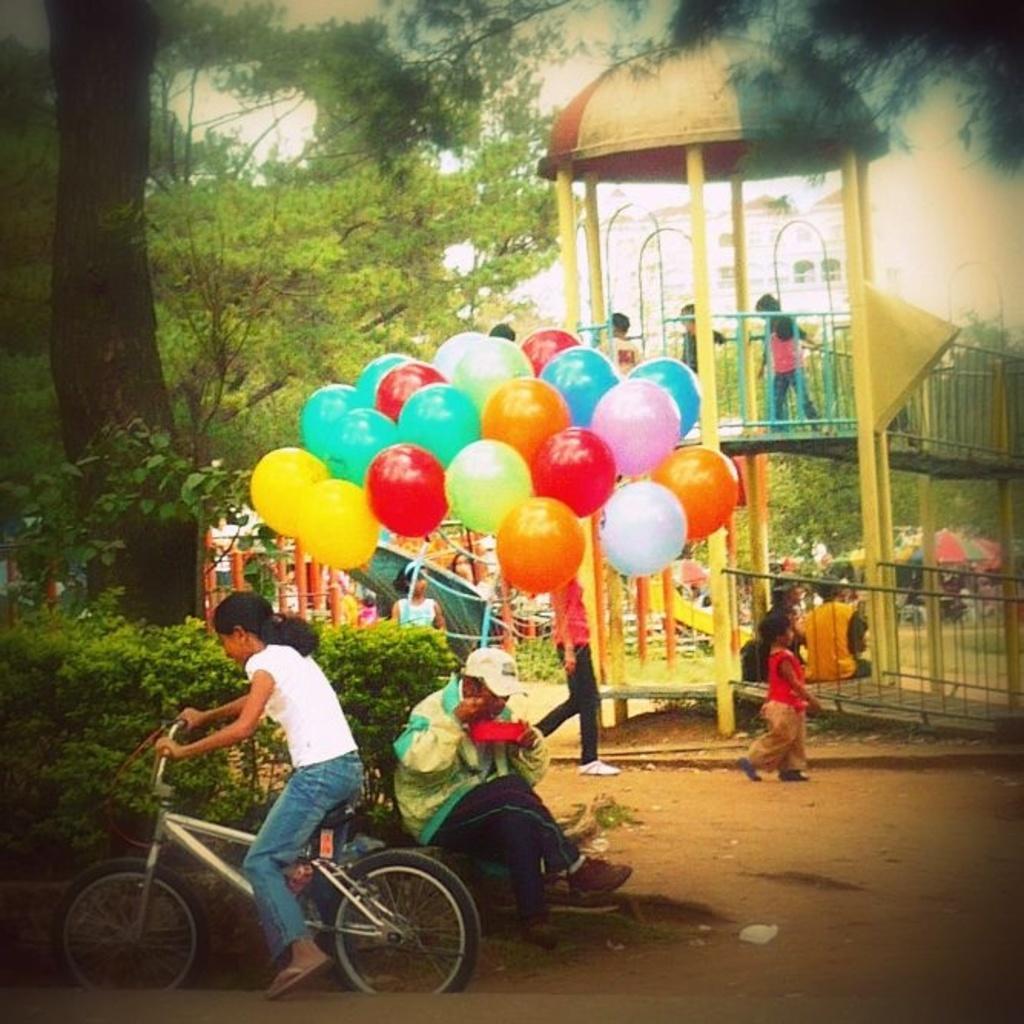How would you summarize this image in a sentence or two? In this image I can see a person siting on the bicycle. At the back ground there are some balloons,trees and the few children. 